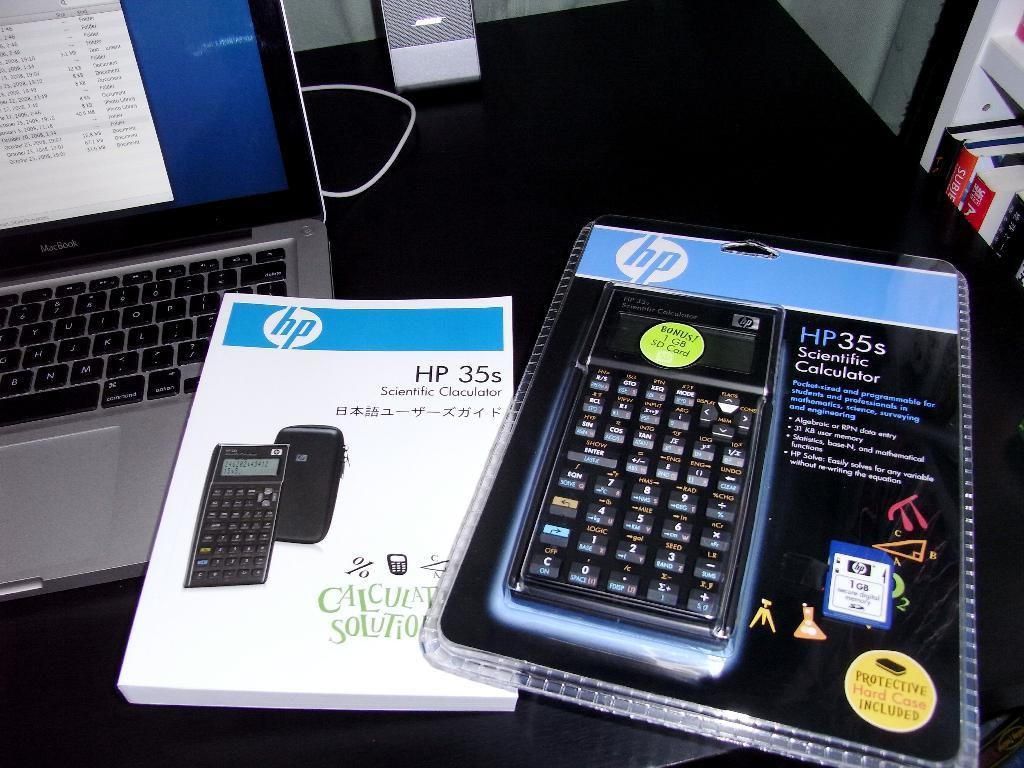<image>
Create a compact narrative representing the image presented. HP35s Scientific calculator in original packaging and manual sitting by a keyboard. 